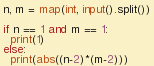Convert code to text. <code><loc_0><loc_0><loc_500><loc_500><_Python_>n, m = map(int, input().split())

if n == 1 and m == 1:
  print(1)
else:
  print(abs((n-2)*(m-2)))</code> 